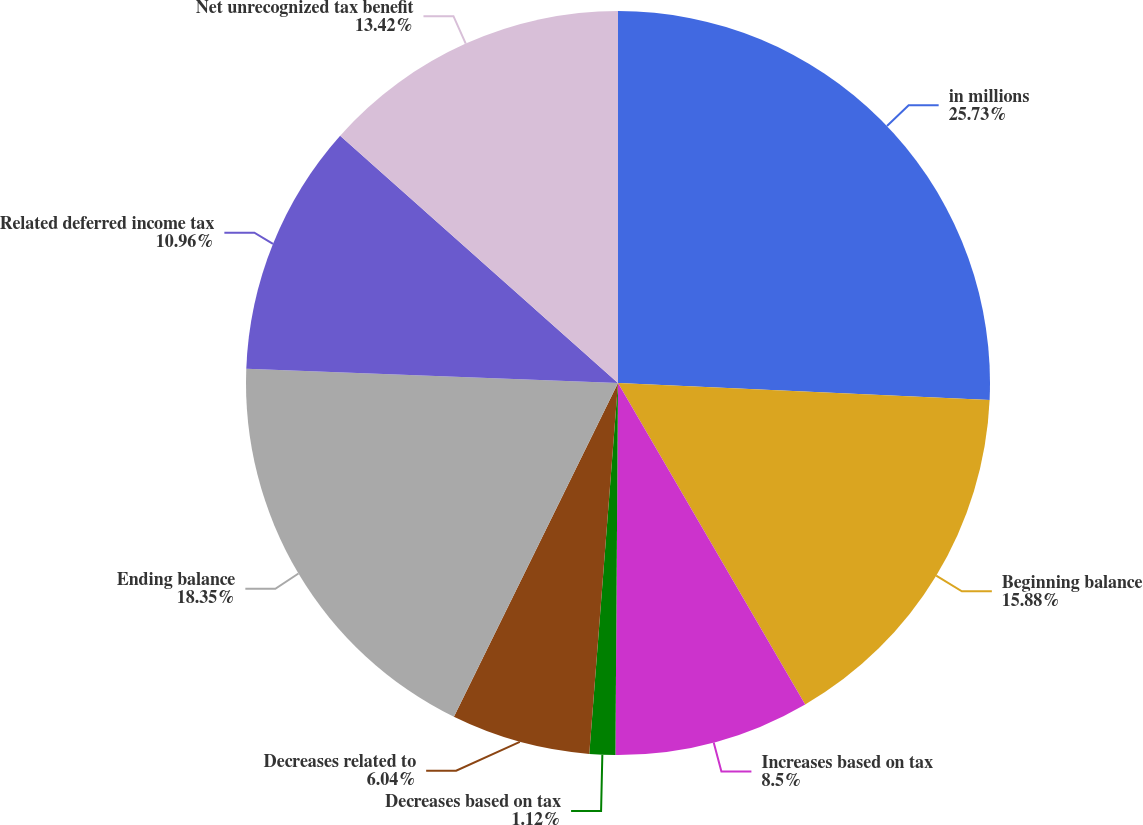Convert chart to OTSL. <chart><loc_0><loc_0><loc_500><loc_500><pie_chart><fcel>in millions<fcel>Beginning balance<fcel>Increases based on tax<fcel>Decreases based on tax<fcel>Decreases related to<fcel>Ending balance<fcel>Related deferred income tax<fcel>Net unrecognized tax benefit<nl><fcel>25.72%<fcel>15.88%<fcel>8.5%<fcel>1.12%<fcel>6.04%<fcel>18.34%<fcel>10.96%<fcel>13.42%<nl></chart> 